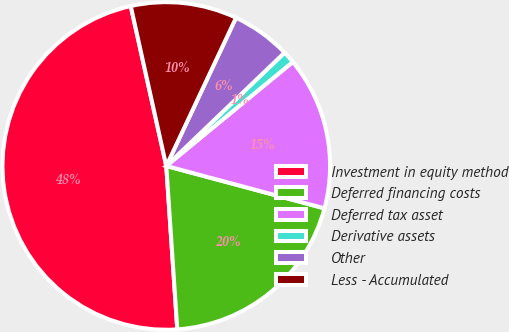<chart> <loc_0><loc_0><loc_500><loc_500><pie_chart><fcel>Investment in equity method<fcel>Deferred financing costs<fcel>Deferred tax asset<fcel>Derivative assets<fcel>Other<fcel>Less - Accumulated<nl><fcel>47.59%<fcel>19.76%<fcel>15.12%<fcel>1.21%<fcel>5.84%<fcel>10.48%<nl></chart> 